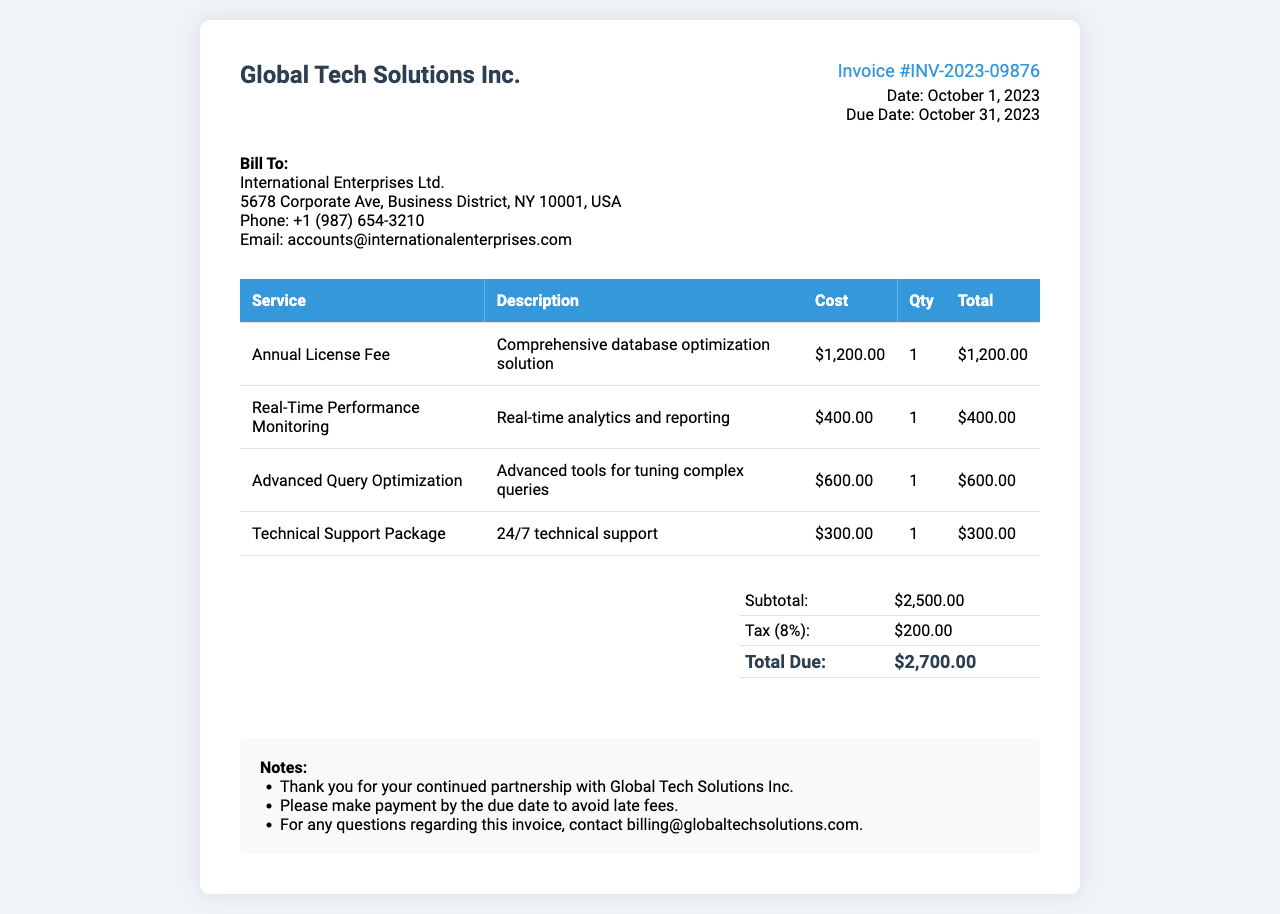what is the invoice number? The invoice number for this document is clearly stated in the header section.
Answer: INV-2023-09876 who is the bill to? The "Bill To" section provides the name of the company receiving the invoice.
Answer: International Enterprises Ltd what is the total due? The total due is calculated in the summary table, including all charges and taxes.
Answer: $2,700.00 what is the cost of the Annual License Fee? This fee is listed under the services section in the invoice table.
Answer: $1,200.00 how much is charged for Technical Support Package? The charge can be found in the services section, specifically for the Technical Support Package.
Answer: $300.00 what is the tax rate applied? The tax rate is mentioned in the summary table as a percentage.
Answer: 8% which service has the highest cost? The service with the highest cost can be identified in the invoice table.
Answer: Annual License Fee when is the due date for this invoice? The due date is specified in the invoice details section in the header.
Answer: October 31, 2023 what is included in the notes section? The notes section provides additional information but does not specify services or costs.
Answer: Payment instructions and contact information 